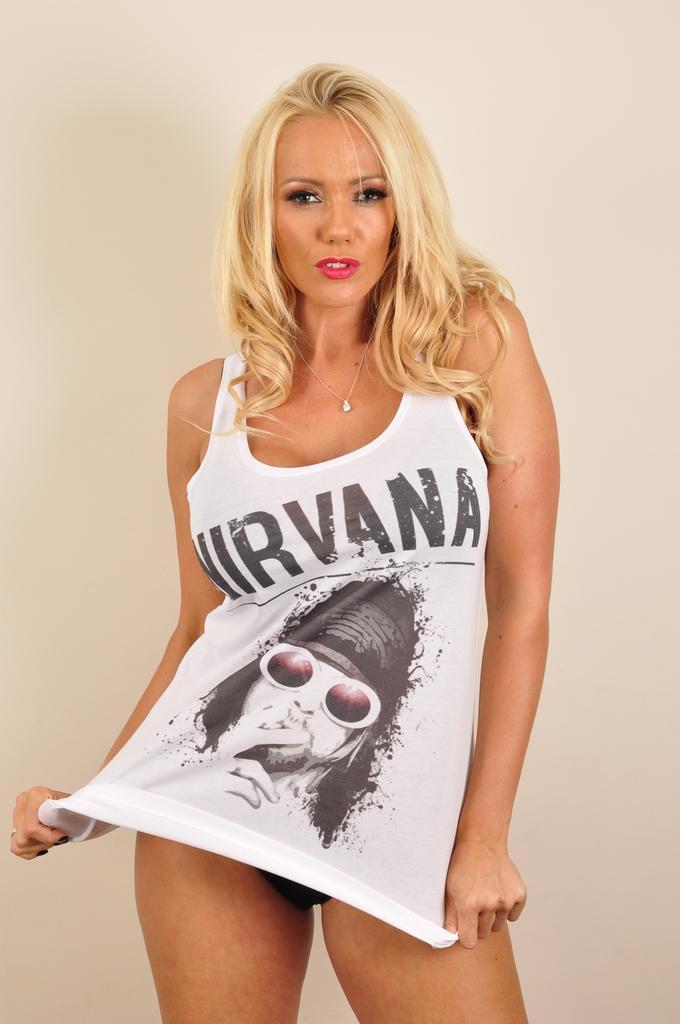Can you describe this image briefly? In the middle of the image we can see a woman. 